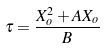<formula> <loc_0><loc_0><loc_500><loc_500>\tau = \frac { X _ { o } ^ { 2 } + A X _ { o } } { B }</formula> 